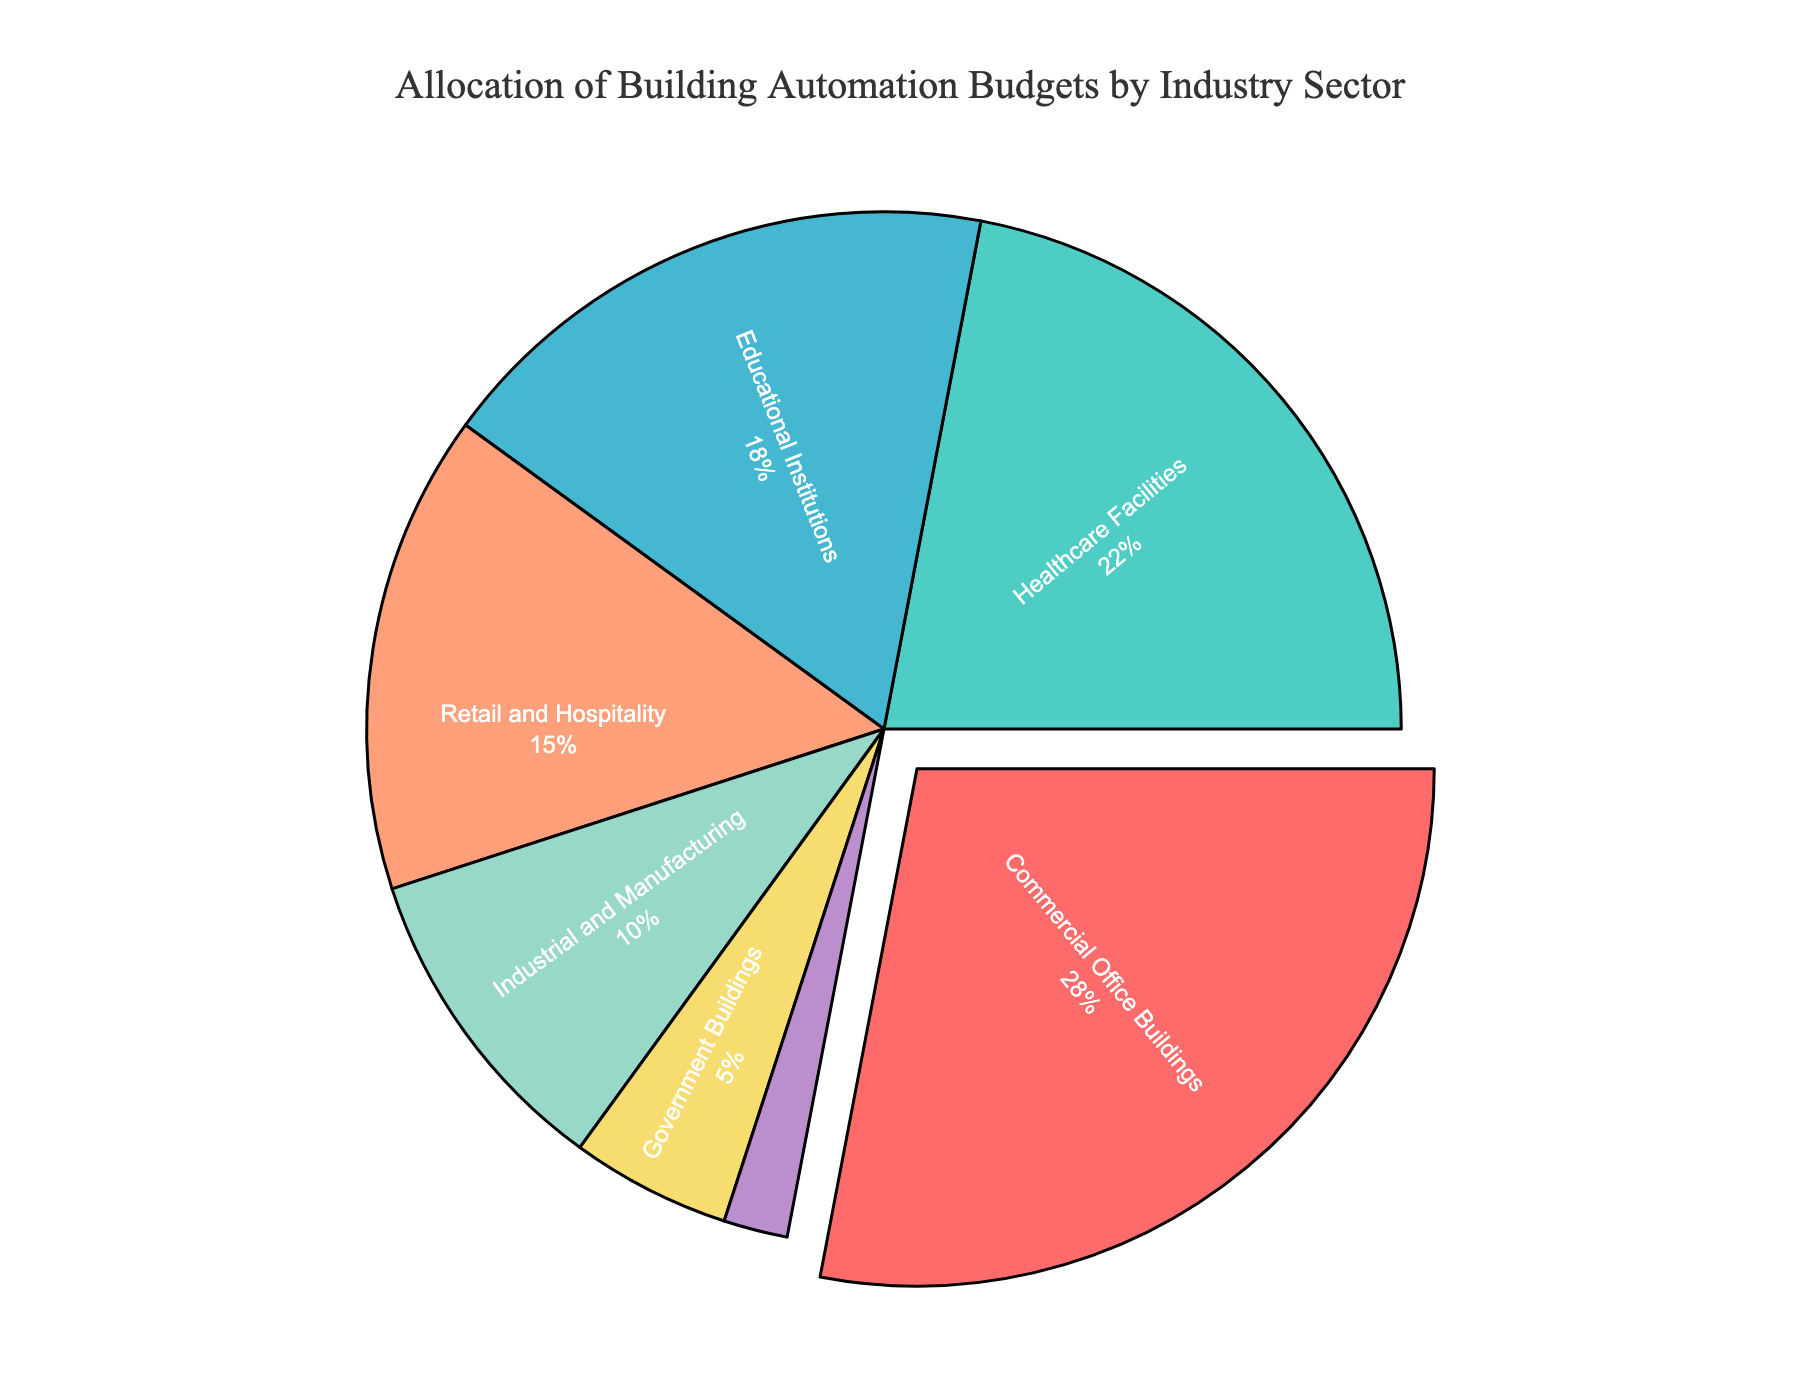What's the industry sector with the highest budget allocation? The commercial office buildings sector has the highest percentage allocation in the pie chart.
Answer: Commercial Office Buildings What fraction of the budget do healthcare facilities receive compared to retail and hospitality? The budget for healthcare facilities is 22%, and for retail and hospitality, it's 15%. To compare them as a fraction: 22/15 = 1.47.
Answer: 1.47 What's the combined budget allocation percentage for government buildings and residential complexes? The budget allocations are 5% for government buildings and 2% for residential complexes. Summing them up: 5% + 2% = 7%.
Answer: 7% Which sector has a lower budget allocation: industrial and manufacturing or residential complexes? Industrial and manufacturing has 10%, and residential complexes have 2%. 2% is lower.
Answer: Residential Complexes How many sectors have a budget allocation greater than 20%? Commercial office buildings have 28%, and healthcare facilities have 22%. Thus, there are two sectors with allocation greater than 20%.
Answer: 2 What is the percentage difference between the highest and lowest budget allocation sectors? The highest allocation is 28% (commercial office buildings) and the lowest is 2% (residential complexes). The difference is 28% - 2% = 26%.
Answer: 26% If the total budget is $1,000,000, how much is allocated to educational institutions? The percentage for educational institutions is 18%. 18% of $1,000,000 is (18/100) * $1,000,000 = $180,000.
Answer: $180,000 Which sector is represented by a blue slice in the pie chart? According to the color scheme in the code, the third color is blue, which corresponds to educational institutions.
Answer: Educational Institutions What is the ratio of budget allocation between commercial office buildings and industrial and manufacturing sectors? The budget allocations are 28% and 10% respectively. The ratio is 28:10 or simplified, 2.8:1.
Answer: 2.8:1 How much larger is the budget allocation for retail and hospitality compared to residential complexes? Retail and hospitality have 15%, and residential complexes have 2%. The difference is 15% - 2% = 13%.
Answer: 13% 